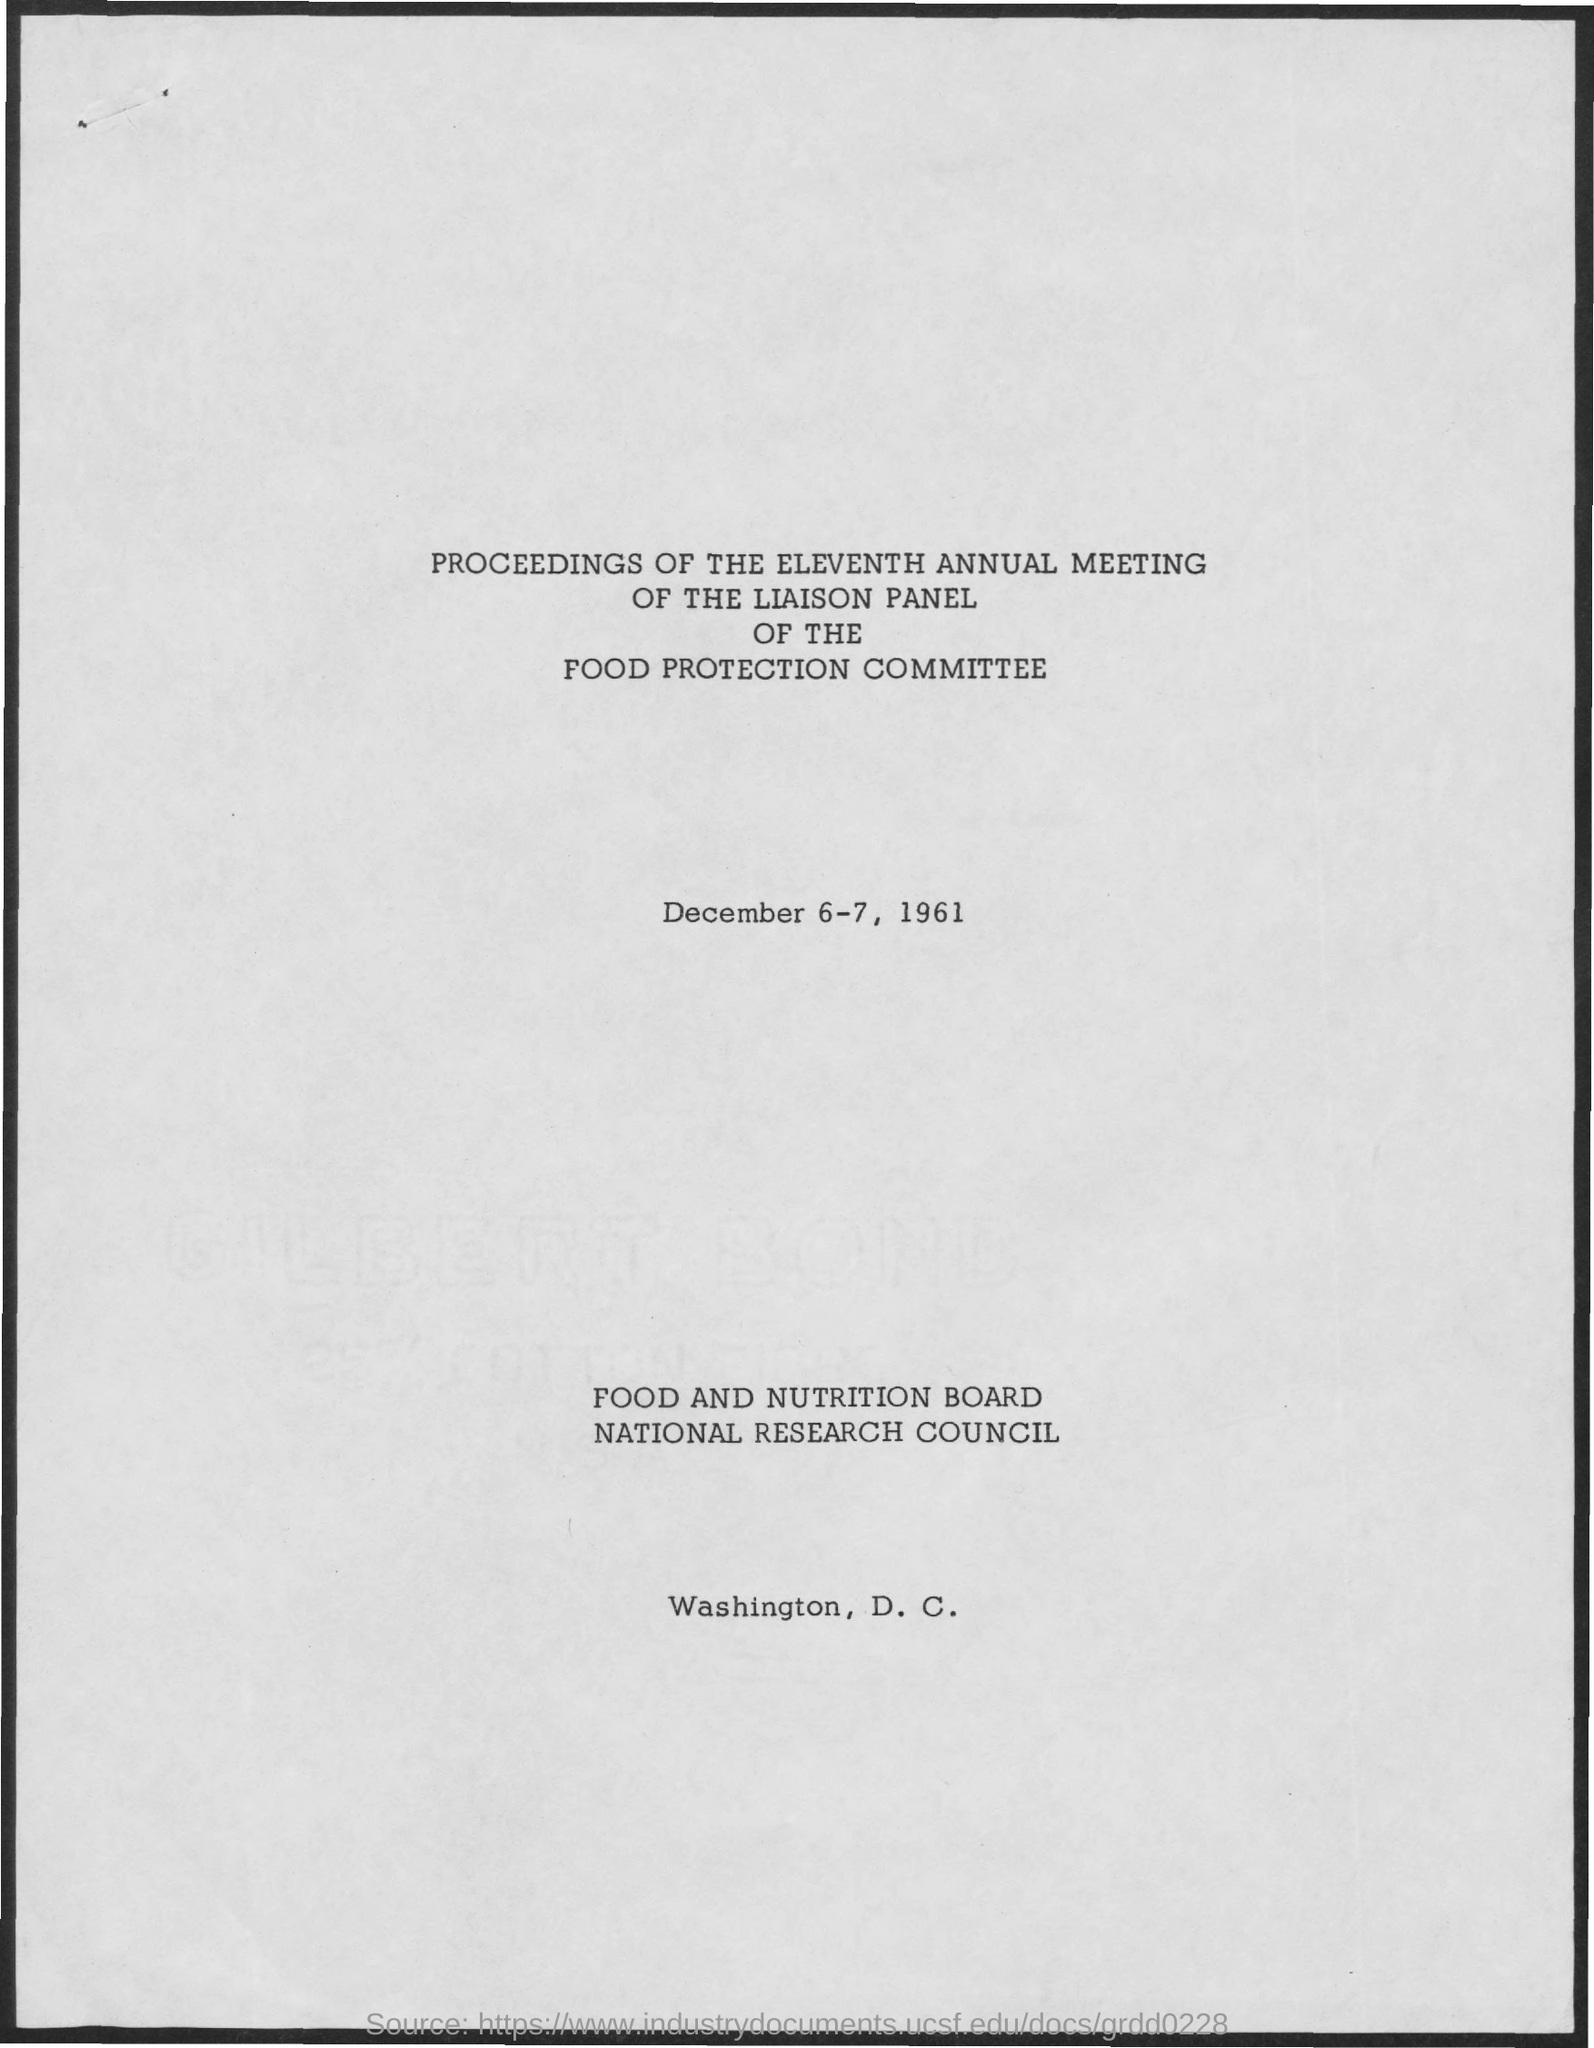When is the meeting?
Make the answer very short. December 6-7, 1961. Where is the location of the food and nutrition board national research council?
Your answer should be compact. Washington, D. C. 